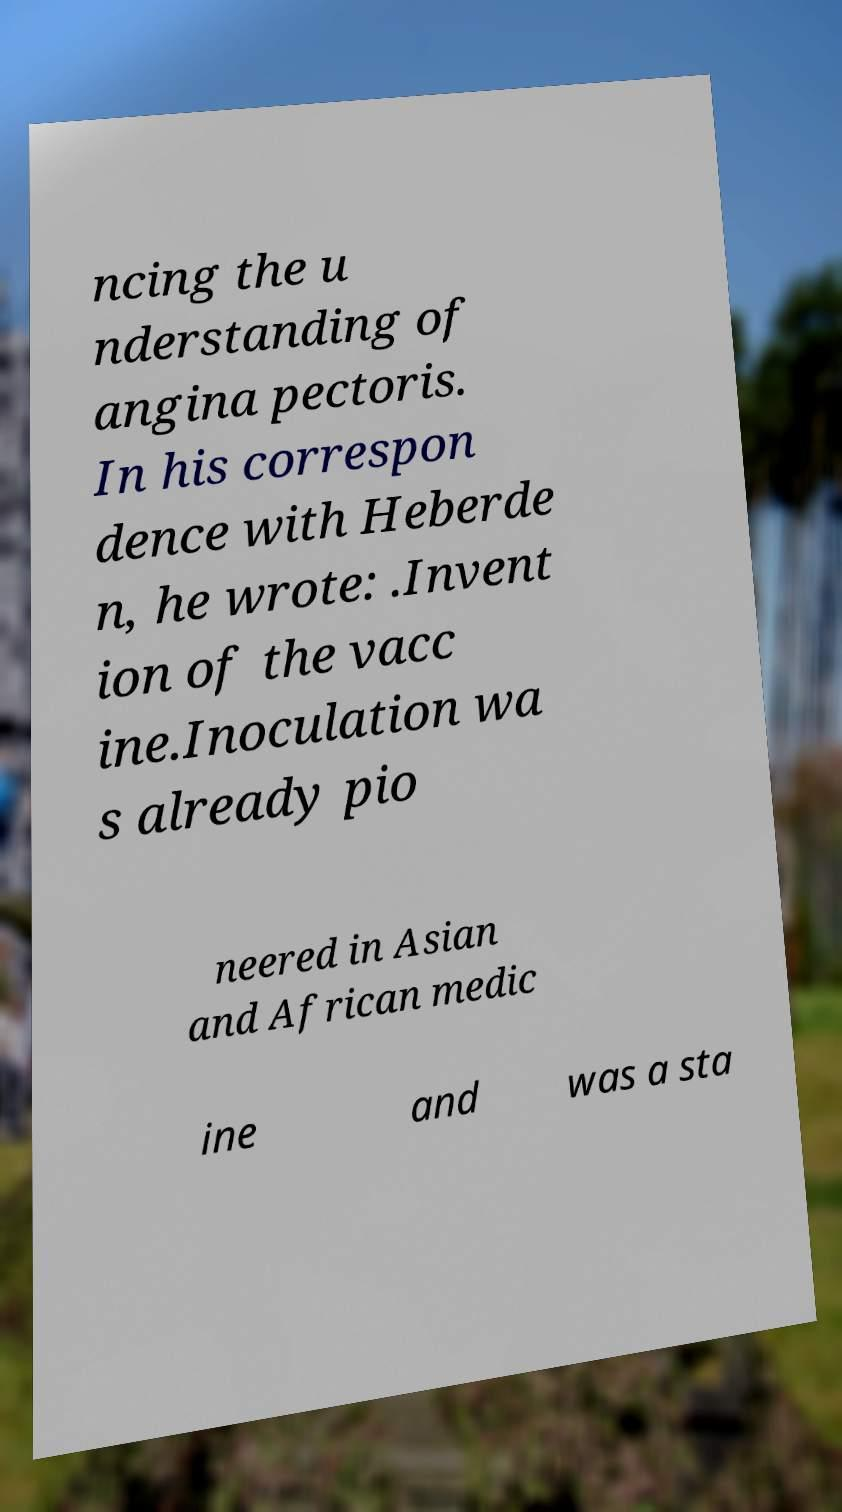Could you extract and type out the text from this image? ncing the u nderstanding of angina pectoris. In his correspon dence with Heberde n, he wrote: .Invent ion of the vacc ine.Inoculation wa s already pio neered in Asian and African medic ine and was a sta 